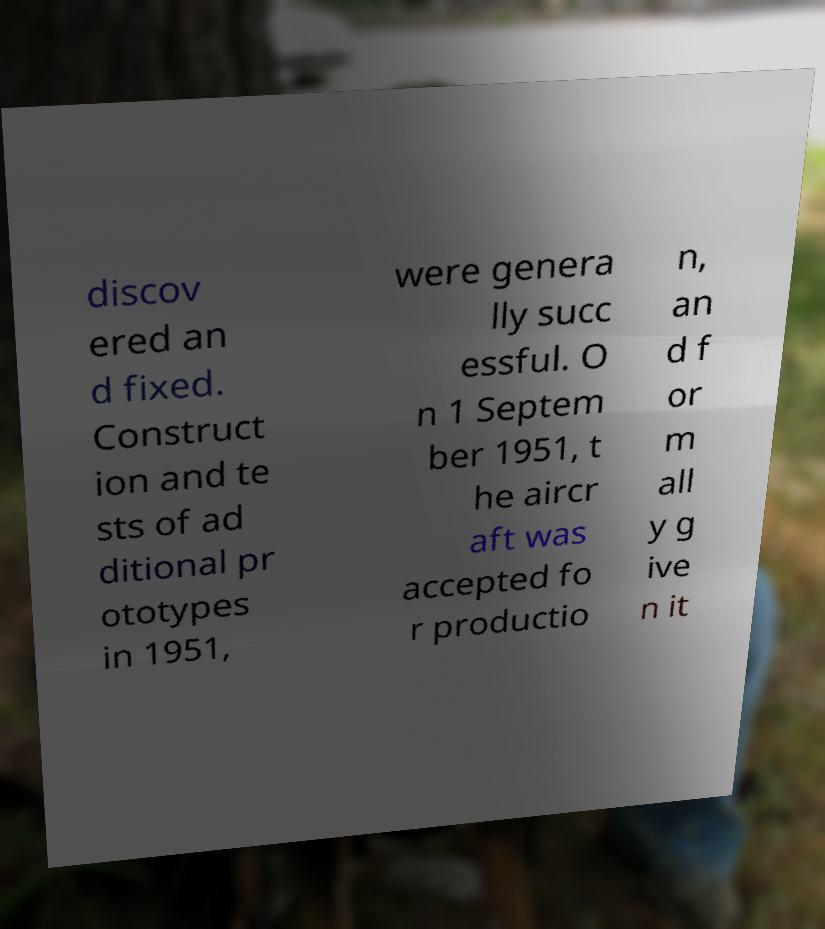What messages or text are displayed in this image? I need them in a readable, typed format. discov ered an d fixed. Construct ion and te sts of ad ditional pr ototypes in 1951, were genera lly succ essful. O n 1 Septem ber 1951, t he aircr aft was accepted fo r productio n, an d f or m all y g ive n it 